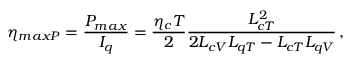<formula> <loc_0><loc_0><loc_500><loc_500>\eta _ { \max P } = \frac { P _ { \max } } { I _ { q } } = \frac { \eta _ { c } T } { 2 } \frac { L _ { c T } ^ { 2 } } { 2 L _ { c V } L _ { q T } - L _ { c T } L _ { q V } } \, ,</formula> 